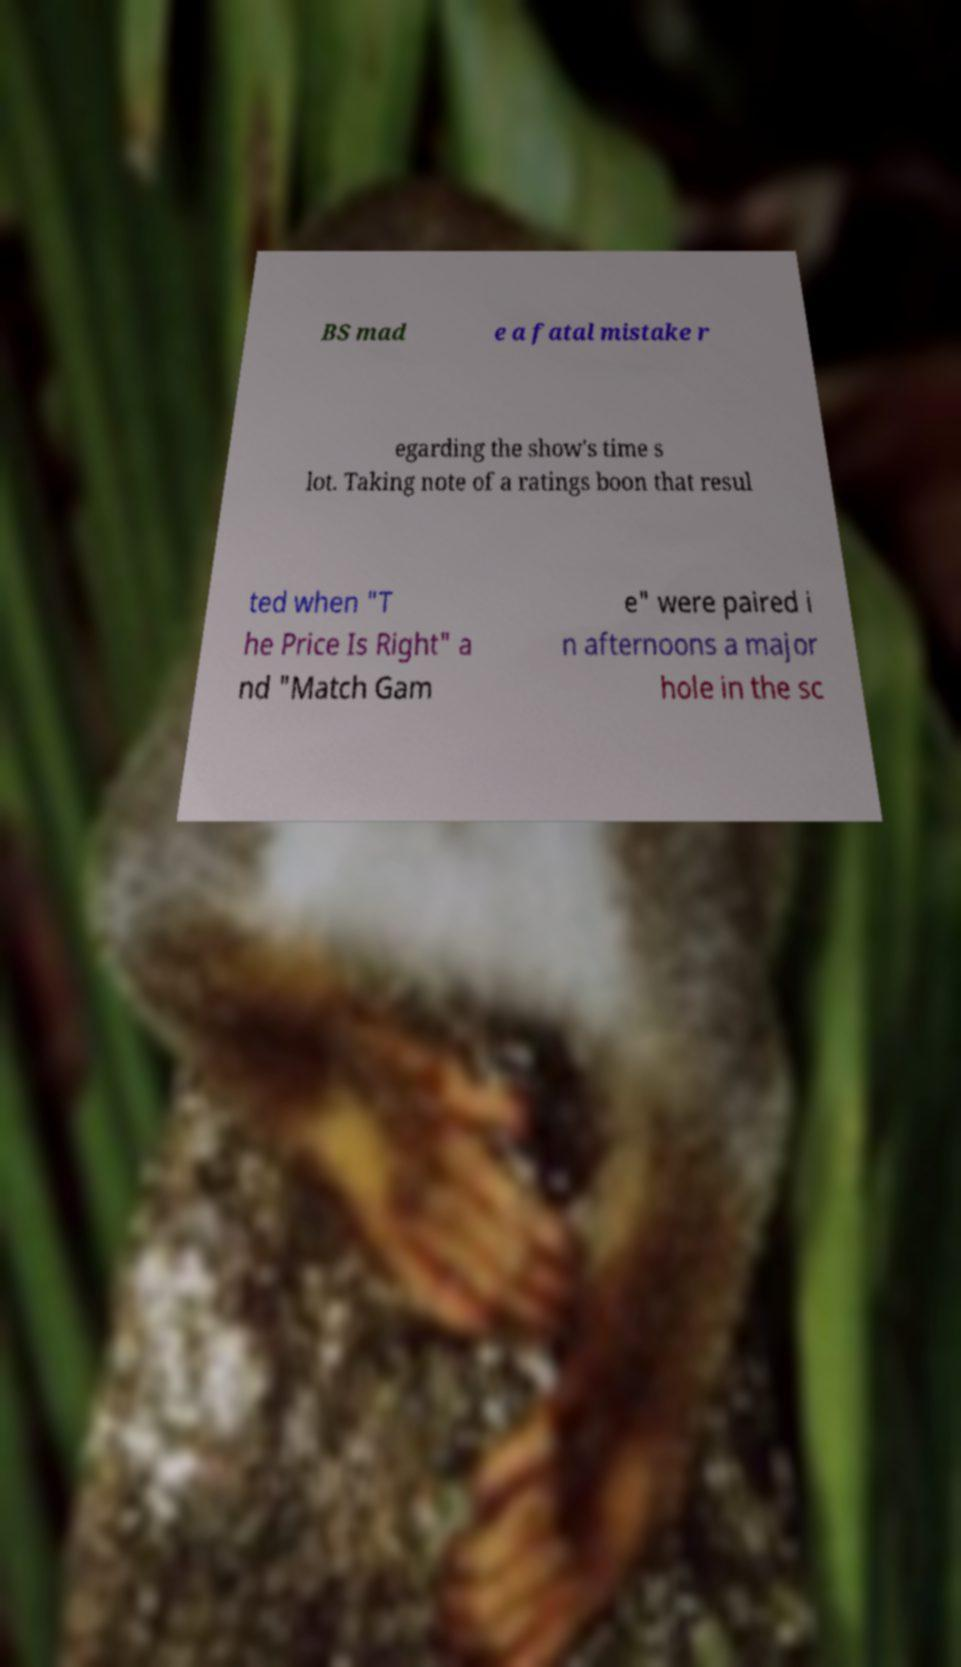For documentation purposes, I need the text within this image transcribed. Could you provide that? BS mad e a fatal mistake r egarding the show's time s lot. Taking note of a ratings boon that resul ted when "T he Price Is Right" a nd "Match Gam e" were paired i n afternoons a major hole in the sc 